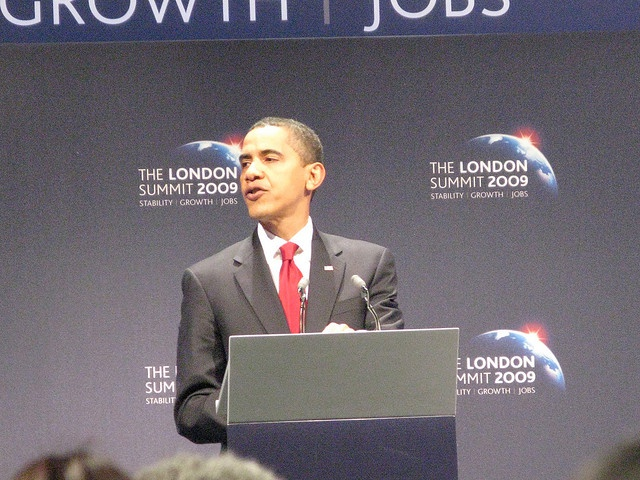Describe the objects in this image and their specific colors. I can see people in lavender, gray, darkgray, tan, and ivory tones and tie in lavender, salmon, brown, and lightpink tones in this image. 